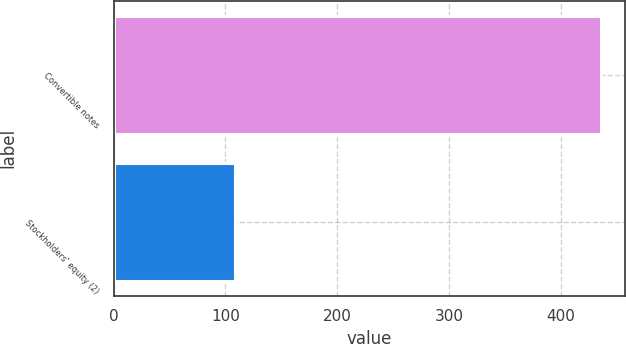Convert chart to OTSL. <chart><loc_0><loc_0><loc_500><loc_500><bar_chart><fcel>Convertible notes<fcel>Stockholders' equity (2)<nl><fcel>436<fcel>108.4<nl></chart> 